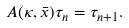<formula> <loc_0><loc_0><loc_500><loc_500>A ( \kappa , \bar { x } ) \tau _ { n } = \tau _ { n + 1 } .</formula> 